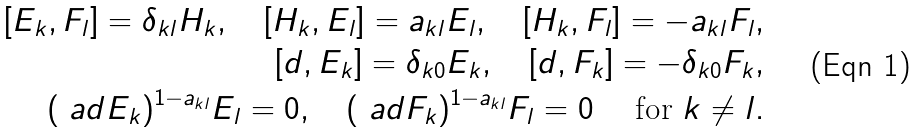<formula> <loc_0><loc_0><loc_500><loc_500>[ E _ { k } , F _ { l } ] = \delta _ { k l } H _ { k } , \quad [ H _ { k } , E _ { l } ] = a _ { k l } E _ { l } , \quad [ H _ { k } , F _ { l } ] = - a _ { k l } F _ { l } , \\ [ d , E _ { k } ] = \delta _ { k 0 } E _ { k } , \quad [ d , F _ { k } ] = - \delta _ { k 0 } F _ { k } , \\ ( \ a d E _ { k } ) ^ { 1 - a _ { k l } } E _ { l } = 0 , \quad ( \ a d F _ { k } ) ^ { 1 - a _ { k l } } F _ { l } = 0 \quad \text { for } k \ne l .</formula> 